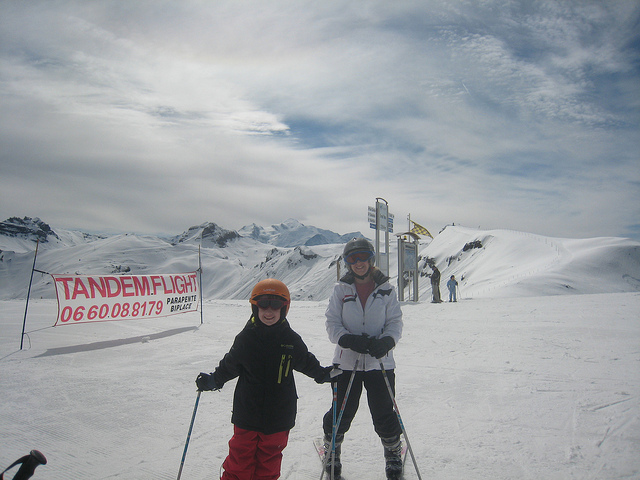<image>What country was this picture from? It is unknown what country the picture is from. It might be Sweden, the United States, Canada, or Switzerland. What country was this picture from? I am not sure what country the picture is from. It can be from Sweden, America, Canada, or Switzerland. 